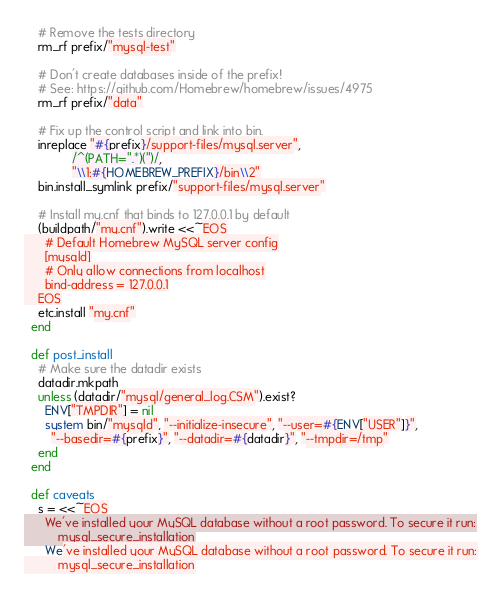<code> <loc_0><loc_0><loc_500><loc_500><_Ruby_>    # Remove the tests directory
    rm_rf prefix/"mysql-test"

    # Don't create databases inside of the prefix!
    # See: https://github.com/Homebrew/homebrew/issues/4975
    rm_rf prefix/"data"

    # Fix up the control script and link into bin.
    inreplace "#{prefix}/support-files/mysql.server",
              /^(PATH=".*)(")/,
              "\\1:#{HOMEBREW_PREFIX}/bin\\2"
    bin.install_symlink prefix/"support-files/mysql.server"

    # Install my.cnf that binds to 127.0.0.1 by default
    (buildpath/"my.cnf").write <<~EOS
      # Default Homebrew MySQL server config
      [mysqld]
      # Only allow connections from localhost
      bind-address = 127.0.0.1
    EOS
    etc.install "my.cnf"
  end

  def post_install
    # Make sure the datadir exists
    datadir.mkpath
    unless (datadir/"mysql/general_log.CSM").exist?
      ENV["TMPDIR"] = nil
      system bin/"mysqld", "--initialize-insecure", "--user=#{ENV["USER"]}",
        "--basedir=#{prefix}", "--datadir=#{datadir}", "--tmpdir=/tmp"
    end
  end

  def caveats
    s = <<~EOS
      We've installed your MySQL database without a root password. To secure it run:
          mysql_secure_installation
</code> 